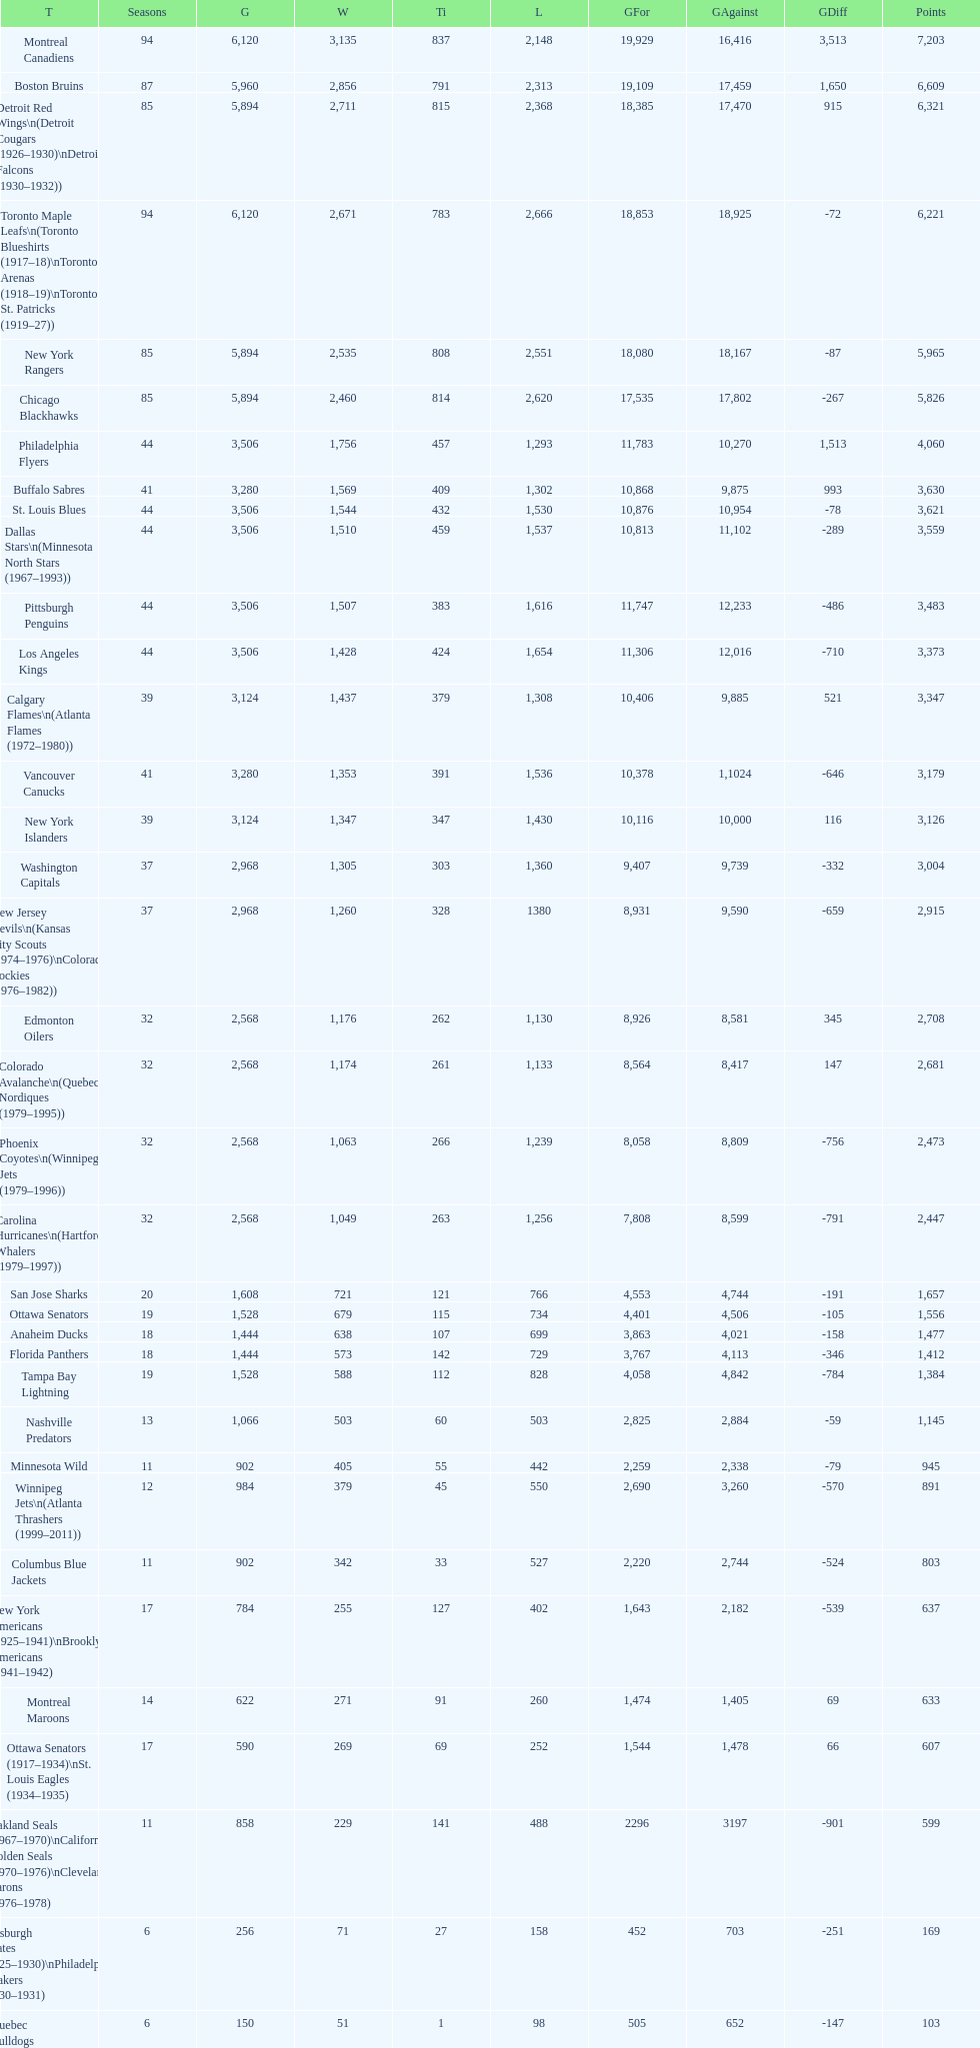Who has the least amount of losses? Montreal Wanderers. 